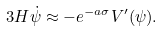Convert formula to latex. <formula><loc_0><loc_0><loc_500><loc_500>3 H \dot { \psi } \approx - e ^ { - a \sigma } V ^ { \prime } ( \psi ) .</formula> 